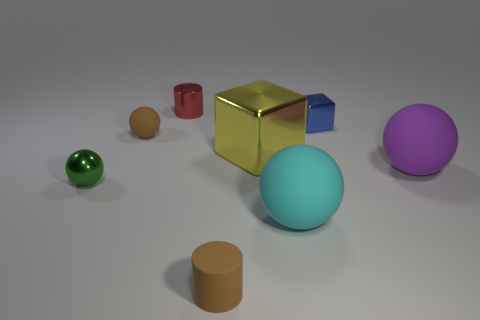Subtract all green balls. How many balls are left? 3 Add 1 small blue metallic things. How many objects exist? 9 Subtract all purple balls. How many balls are left? 3 Subtract all cylinders. How many objects are left? 6 Subtract all green balls. Subtract all yellow cylinders. How many balls are left? 3 Subtract all blue metallic cubes. Subtract all big yellow cubes. How many objects are left? 6 Add 8 blue metallic blocks. How many blue metallic blocks are left? 9 Add 8 purple rubber objects. How many purple rubber objects exist? 9 Subtract 0 yellow cylinders. How many objects are left? 8 Subtract 2 balls. How many balls are left? 2 